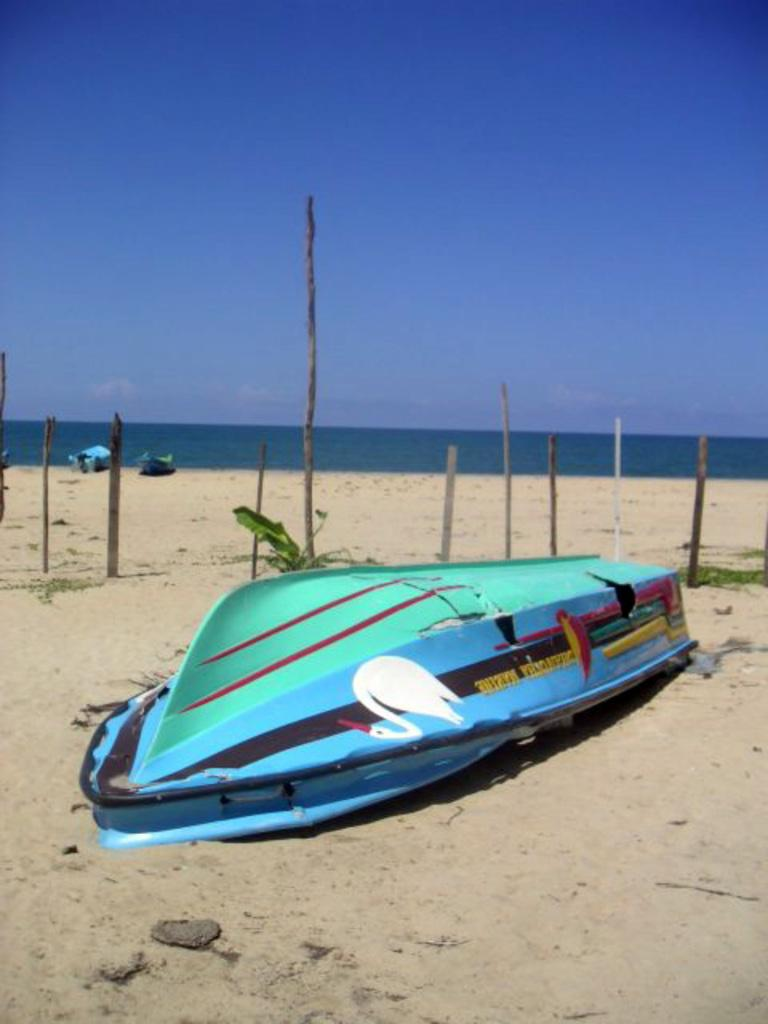What objects are on the ground in the image? There are boats on the ground in the image. What is the primary element visible in the image? There is water visible in the image. How would you describe the sky in the image? The sky is blue and cloudy in the image. Where is the knife being used in the image? There is no knife present in the image. What type of crow can be seen interacting with the boats in the image? There are no crows or interactions with the boats in the image. 